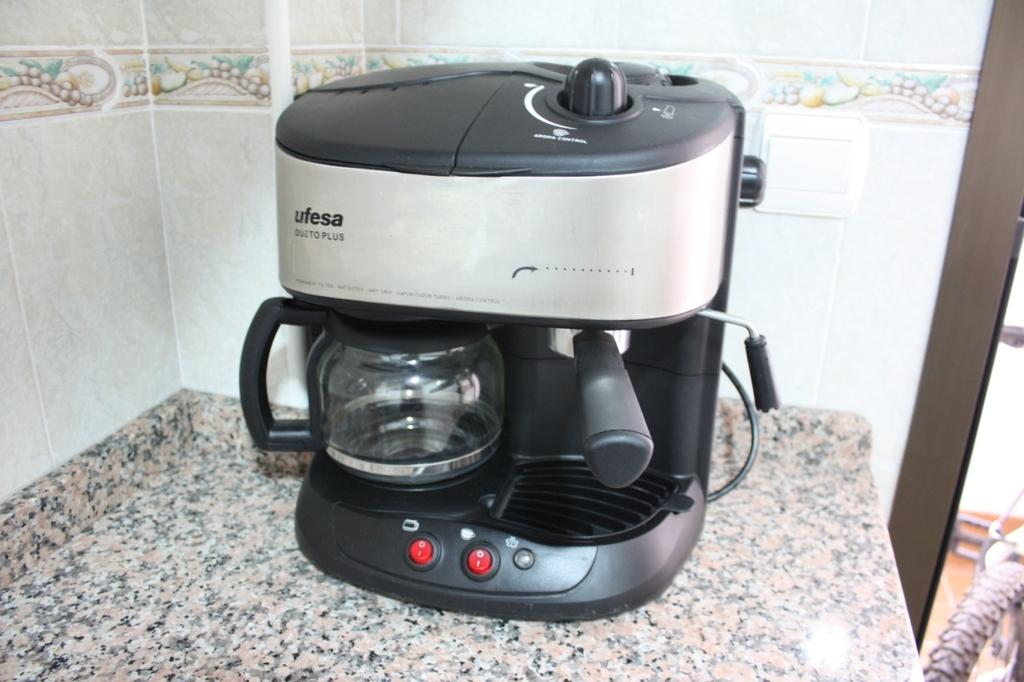Provide a one-sentence caption for the provided image. A black and silver espresso maker made by ufesa. 